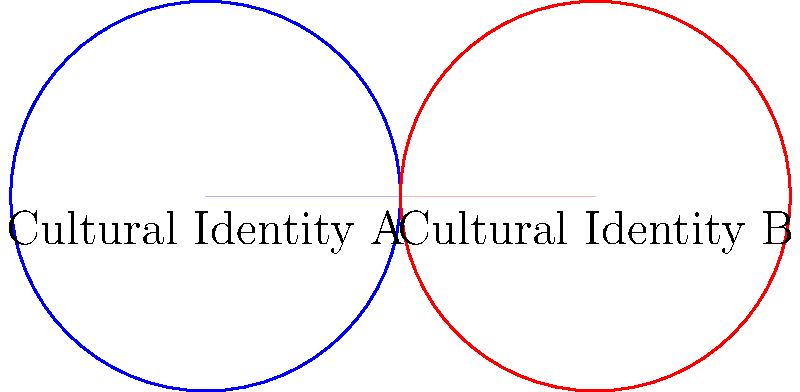In your research on the influence of names on personal identity, you're studying the overlap of cultural identities. Two cultural identities are represented by circles with radius 1 unit, and their centers are 2 units apart. Calculate the area of the overlapping region (representing individuals who identify with both cultures) to the nearest hundredth. Use $\pi \approx 3.14$ for your calculations. To find the area of the overlapping region, we'll follow these steps:

1) First, we need to find the angle $\theta$ at the center of each circle that forms the overlapping region:
   $\cos(\frac{\theta}{2}) = \frac{1}{2}$
   $\theta = 2 \arccos(\frac{1}{2}) \approx 2.0944$ radians

2) The area of the overlapping region is twice the area of a circular sector minus the area of an equilateral triangle:

   Area = $2 (\frac{1}{2} r^2 \theta - \frac{1}{2} r^2 \sin(\theta))$

3) Substituting the values:
   Area = $2 (\frac{1}{2} \cdot 1^2 \cdot 2.0944 - \frac{1}{2} \cdot 1^2 \cdot \sin(2.0944))$
        = $2 (1.0472 - 0.8660)$
        = $2 (0.1812)$
        = $0.3624$

4) Rounding to the nearest hundredth:
   Area $\approx 0.36$ square units

This represents the proportion of individuals who identify with both cultural identities in your study.
Answer: $0.36$ square units 